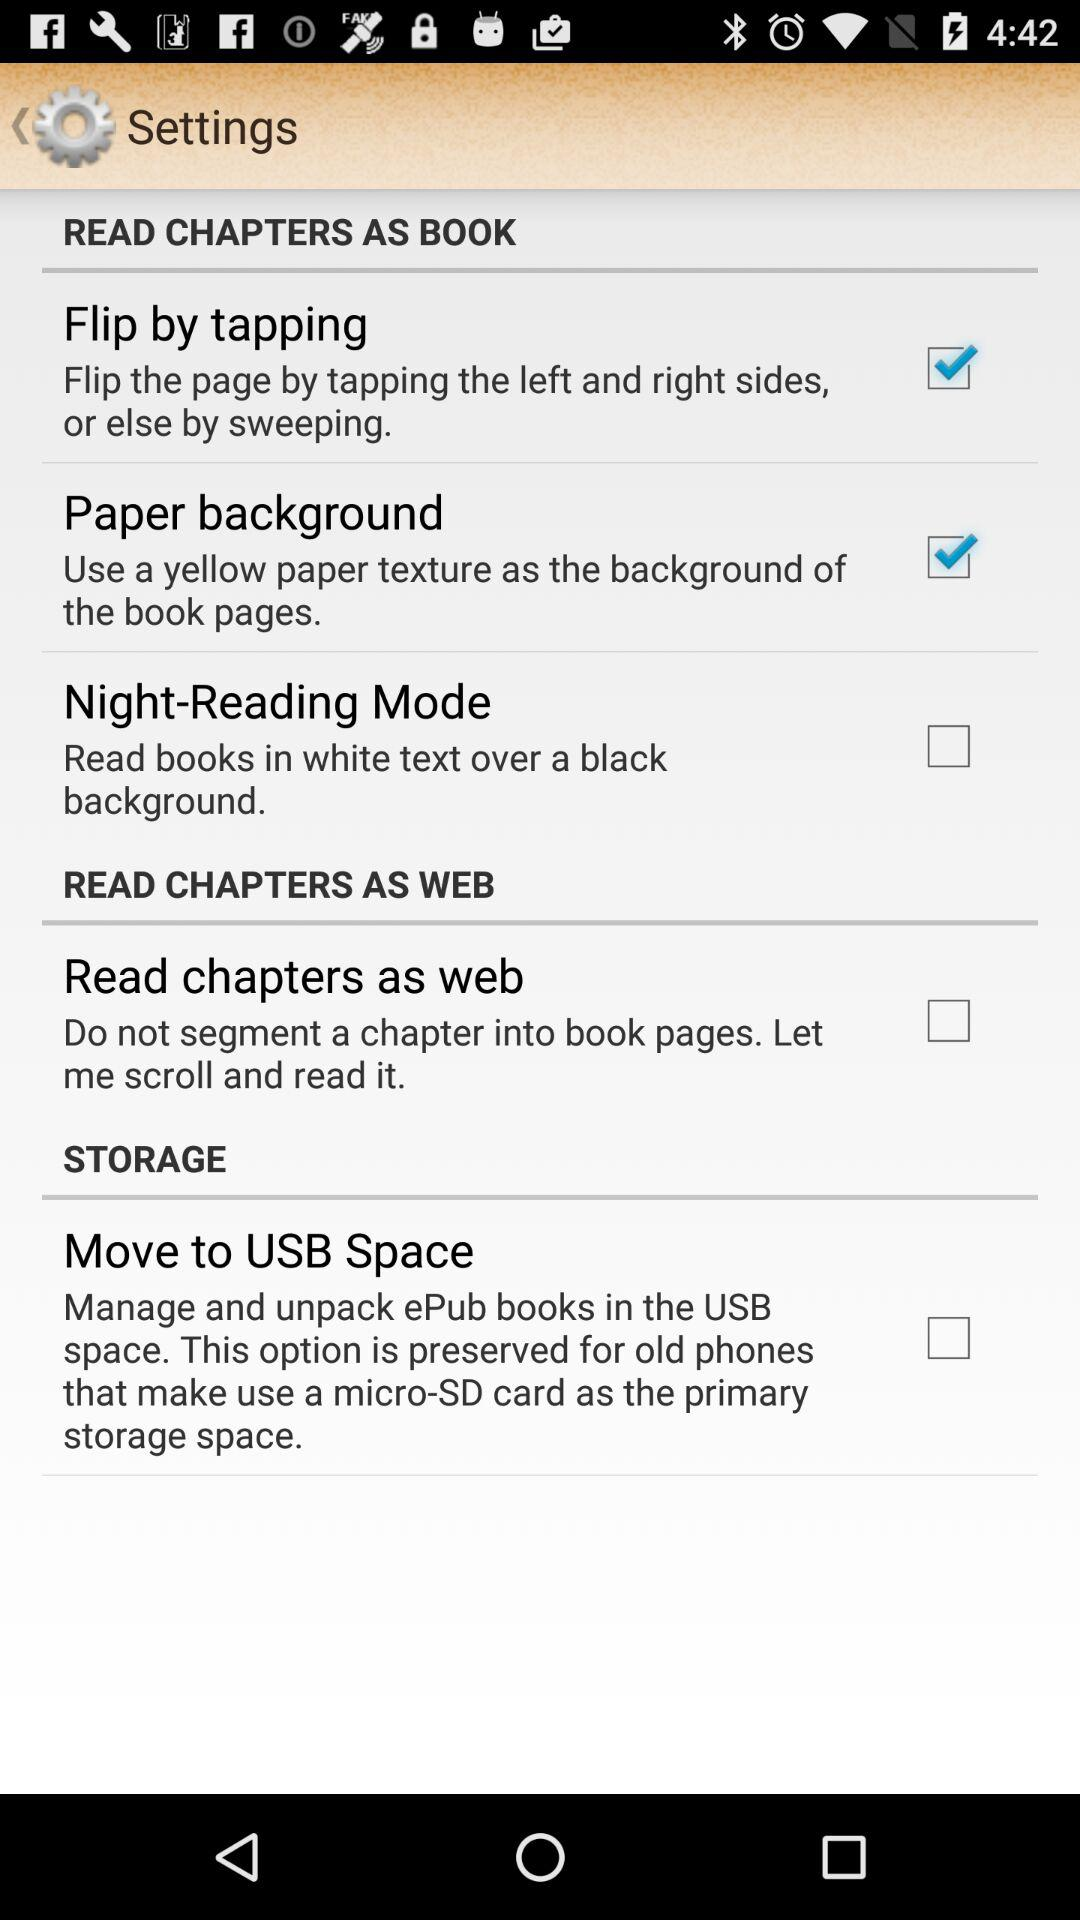How many checkboxes are checked on this page?
Answer the question using a single word or phrase. 2 